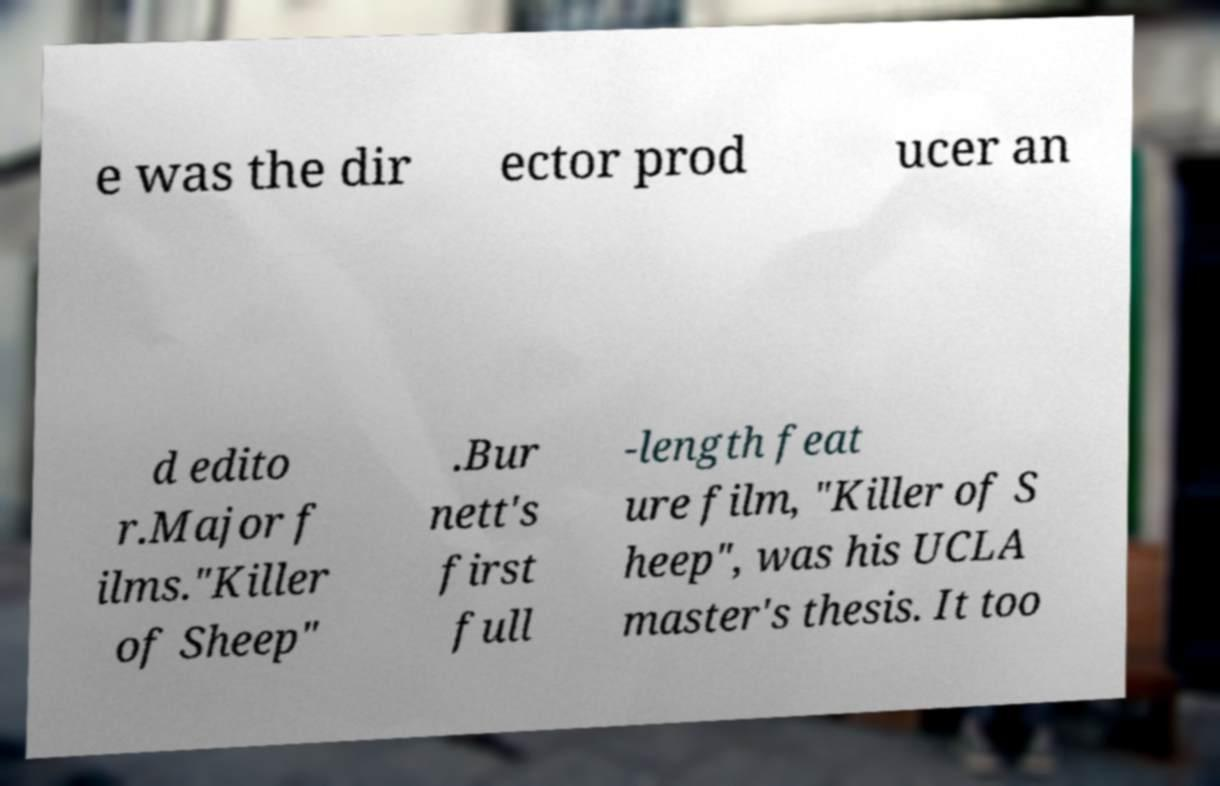What messages or text are displayed in this image? I need them in a readable, typed format. e was the dir ector prod ucer an d edito r.Major f ilms."Killer of Sheep" .Bur nett's first full -length feat ure film, "Killer of S heep", was his UCLA master's thesis. It too 